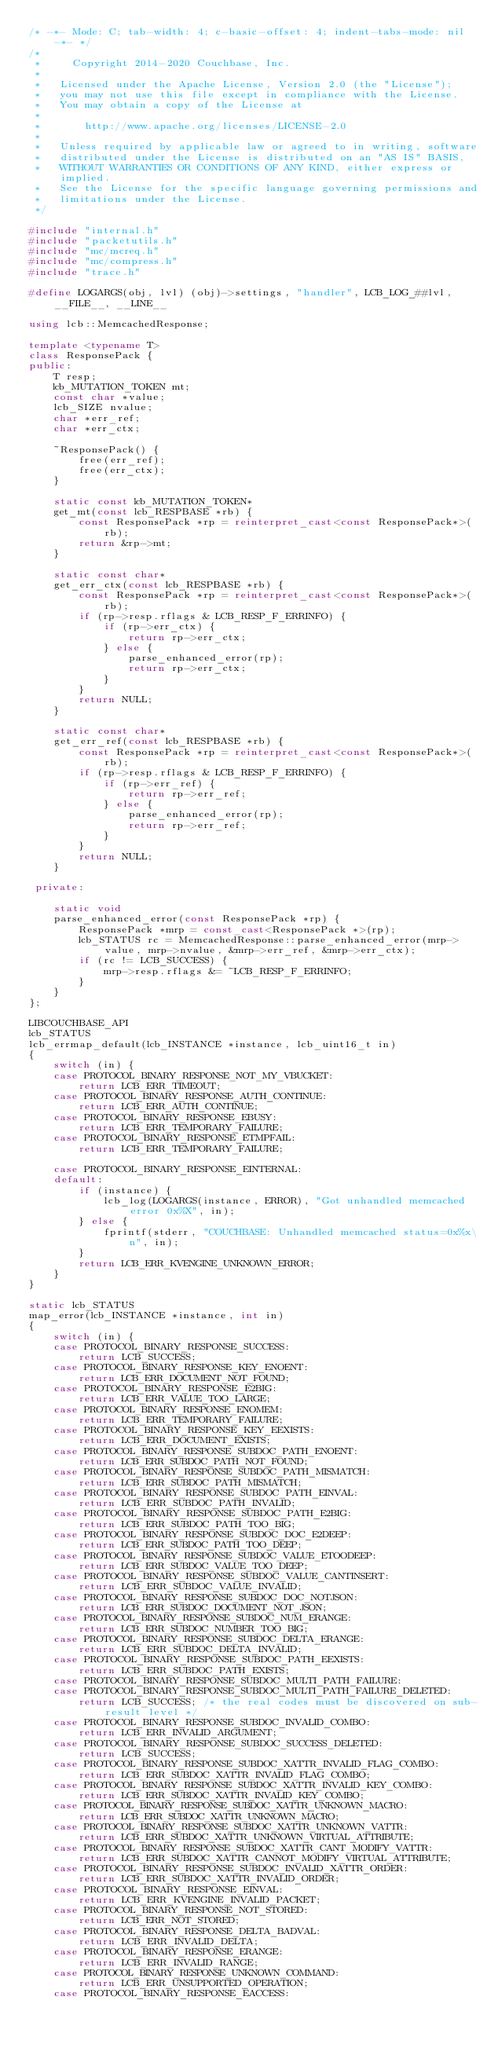<code> <loc_0><loc_0><loc_500><loc_500><_C++_>/* -*- Mode: C; tab-width: 4; c-basic-offset: 4; indent-tabs-mode: nil -*- */
/*
 *     Copyright 2014-2020 Couchbase, Inc.
 *
 *   Licensed under the Apache License, Version 2.0 (the "License");
 *   you may not use this file except in compliance with the License.
 *   You may obtain a copy of the License at
 *
 *       http://www.apache.org/licenses/LICENSE-2.0
 *
 *   Unless required by applicable law or agreed to in writing, software
 *   distributed under the License is distributed on an "AS IS" BASIS,
 *   WITHOUT WARRANTIES OR CONDITIONS OF ANY KIND, either express or implied.
 *   See the License for the specific language governing permissions and
 *   limitations under the License.
 */

#include "internal.h"
#include "packetutils.h"
#include "mc/mcreq.h"
#include "mc/compress.h"
#include "trace.h"

#define LOGARGS(obj, lvl) (obj)->settings, "handler", LCB_LOG_##lvl, __FILE__, __LINE__

using lcb::MemcachedResponse;

template <typename T>
class ResponsePack {
public:
    T resp;
    lcb_MUTATION_TOKEN mt;
    const char *value;
    lcb_SIZE nvalue;
    char *err_ref;
    char *err_ctx;

    ~ResponsePack() {
        free(err_ref);
        free(err_ctx);
    }

    static const lcb_MUTATION_TOKEN*
    get_mt(const lcb_RESPBASE *rb) {
        const ResponsePack *rp = reinterpret_cast<const ResponsePack*>(rb);
        return &rp->mt;
    }

    static const char*
    get_err_ctx(const lcb_RESPBASE *rb) {
        const ResponsePack *rp = reinterpret_cast<const ResponsePack*>(rb);
        if (rp->resp.rflags & LCB_RESP_F_ERRINFO) {
            if (rp->err_ctx) {
                return rp->err_ctx;
            } else {
                parse_enhanced_error(rp);
                return rp->err_ctx;
            }
        }
        return NULL;
    }

    static const char*
    get_err_ref(const lcb_RESPBASE *rb) {
        const ResponsePack *rp = reinterpret_cast<const ResponsePack*>(rb);
        if (rp->resp.rflags & LCB_RESP_F_ERRINFO) {
            if (rp->err_ref) {
                return rp->err_ref;
            } else {
                parse_enhanced_error(rp);
                return rp->err_ref;
            }
        }
        return NULL;
    }

 private:

    static void
    parse_enhanced_error(const ResponsePack *rp) {
        ResponsePack *mrp = const_cast<ResponsePack *>(rp);
        lcb_STATUS rc = MemcachedResponse::parse_enhanced_error(mrp->value, mrp->nvalue, &mrp->err_ref, &mrp->err_ctx);
        if (rc != LCB_SUCCESS) {
            mrp->resp.rflags &= ~LCB_RESP_F_ERRINFO;
        }
    }
};

LIBCOUCHBASE_API
lcb_STATUS
lcb_errmap_default(lcb_INSTANCE *instance, lcb_uint16_t in)
{
    switch (in) {
    case PROTOCOL_BINARY_RESPONSE_NOT_MY_VBUCKET:
        return LCB_ERR_TIMEOUT;
    case PROTOCOL_BINARY_RESPONSE_AUTH_CONTINUE:
        return LCB_ERR_AUTH_CONTINUE;
    case PROTOCOL_BINARY_RESPONSE_EBUSY:
        return LCB_ERR_TEMPORARY_FAILURE;
    case PROTOCOL_BINARY_RESPONSE_ETMPFAIL:
        return LCB_ERR_TEMPORARY_FAILURE;

    case PROTOCOL_BINARY_RESPONSE_EINTERNAL:
    default:
        if (instance) {
            lcb_log(LOGARGS(instance, ERROR), "Got unhandled memcached error 0x%X", in);
        } else {
            fprintf(stderr, "COUCHBASE: Unhandled memcached status=0x%x\n", in);
        }
        return LCB_ERR_KVENGINE_UNKNOWN_ERROR;
    }
}

static lcb_STATUS
map_error(lcb_INSTANCE *instance, int in)
{
    switch (in) {
    case PROTOCOL_BINARY_RESPONSE_SUCCESS:
        return LCB_SUCCESS;
    case PROTOCOL_BINARY_RESPONSE_KEY_ENOENT:
        return LCB_ERR_DOCUMENT_NOT_FOUND;
    case PROTOCOL_BINARY_RESPONSE_E2BIG:
        return LCB_ERR_VALUE_TOO_LARGE;
    case PROTOCOL_BINARY_RESPONSE_ENOMEM:
        return LCB_ERR_TEMPORARY_FAILURE;
    case PROTOCOL_BINARY_RESPONSE_KEY_EEXISTS:
        return LCB_ERR_DOCUMENT_EXISTS;
    case PROTOCOL_BINARY_RESPONSE_SUBDOC_PATH_ENOENT:
        return LCB_ERR_SUBDOC_PATH_NOT_FOUND;
    case PROTOCOL_BINARY_RESPONSE_SUBDOC_PATH_MISMATCH:
        return LCB_ERR_SUBDOC_PATH_MISMATCH;
    case PROTOCOL_BINARY_RESPONSE_SUBDOC_PATH_EINVAL:
        return LCB_ERR_SUBDOC_PATH_INVALID;
    case PROTOCOL_BINARY_RESPONSE_SUBDOC_PATH_E2BIG:
        return LCB_ERR_SUBDOC_PATH_TOO_BIG;
    case PROTOCOL_BINARY_RESPONSE_SUBDOC_DOC_E2DEEP:
        return LCB_ERR_SUBDOC_PATH_TOO_DEEP;
    case PROTOCOL_BINARY_RESPONSE_SUBDOC_VALUE_ETOODEEP:
        return LCB_ERR_SUBDOC_VALUE_TOO_DEEP;
    case PROTOCOL_BINARY_RESPONSE_SUBDOC_VALUE_CANTINSERT:
        return LCB_ERR_SUBDOC_VALUE_INVALID;
    case PROTOCOL_BINARY_RESPONSE_SUBDOC_DOC_NOTJSON:
        return LCB_ERR_SUBDOC_DOCUMENT_NOT_JSON;
    case PROTOCOL_BINARY_RESPONSE_SUBDOC_NUM_ERANGE:
        return LCB_ERR_SUBDOC_NUMBER_TOO_BIG;
    case PROTOCOL_BINARY_RESPONSE_SUBDOC_DELTA_ERANGE:
        return LCB_ERR_SUBDOC_DELTA_INVALID;
    case PROTOCOL_BINARY_RESPONSE_SUBDOC_PATH_EEXISTS:
        return LCB_ERR_SUBDOC_PATH_EXISTS;
    case PROTOCOL_BINARY_RESPONSE_SUBDOC_MULTI_PATH_FAILURE:
    case PROTOCOL_BINARY_RESPONSE_SUBDOC_MULTI_PATH_FAILURE_DELETED:
        return LCB_SUCCESS; /* the real codes must be discovered on sub-result level */
    case PROTOCOL_BINARY_RESPONSE_SUBDOC_INVALID_COMBO:
        return LCB_ERR_INVALID_ARGUMENT;
    case PROTOCOL_BINARY_RESPONSE_SUBDOC_SUCCESS_DELETED:
        return LCB_SUCCESS;
    case PROTOCOL_BINARY_RESPONSE_SUBDOC_XATTR_INVALID_FLAG_COMBO:
        return LCB_ERR_SUBDOC_XATTR_INVALID_FLAG_COMBO;
    case PROTOCOL_BINARY_RESPONSE_SUBDOC_XATTR_INVALID_KEY_COMBO:
        return LCB_ERR_SUBDOC_XATTR_INVALID_KEY_COMBO;
    case PROTOCOL_BINARY_RESPONSE_SUBDOC_XATTR_UNKNOWN_MACRO:
        return LCB_ERR_SUBDOC_XATTR_UNKNOWN_MACRO;
    case PROTOCOL_BINARY_RESPONSE_SUBDOC_XATTR_UNKNOWN_VATTR:
        return LCB_ERR_SUBDOC_XATTR_UNKNOWN_VIRTUAL_ATTRIBUTE;
    case PROTOCOL_BINARY_RESPONSE_SUBDOC_XATTR_CANT_MODIFY_VATTR:
        return LCB_ERR_SUBDOC_XATTR_CANNOT_MODIFY_VIRTUAL_ATTRIBUTE;
    case PROTOCOL_BINARY_RESPONSE_SUBDOC_INVALID_XATTR_ORDER:
        return LCB_ERR_SUBDOC_XATTR_INVALID_ORDER;
    case PROTOCOL_BINARY_RESPONSE_EINVAL:
        return LCB_ERR_KVENGINE_INVALID_PACKET;
    case PROTOCOL_BINARY_RESPONSE_NOT_STORED:
        return LCB_ERR_NOT_STORED;
    case PROTOCOL_BINARY_RESPONSE_DELTA_BADVAL:
        return LCB_ERR_INVALID_DELTA;
    case PROTOCOL_BINARY_RESPONSE_ERANGE:
        return LCB_ERR_INVALID_RANGE;
    case PROTOCOL_BINARY_RESPONSE_UNKNOWN_COMMAND:
        return LCB_ERR_UNSUPPORTED_OPERATION;
    case PROTOCOL_BINARY_RESPONSE_EACCESS:</code> 